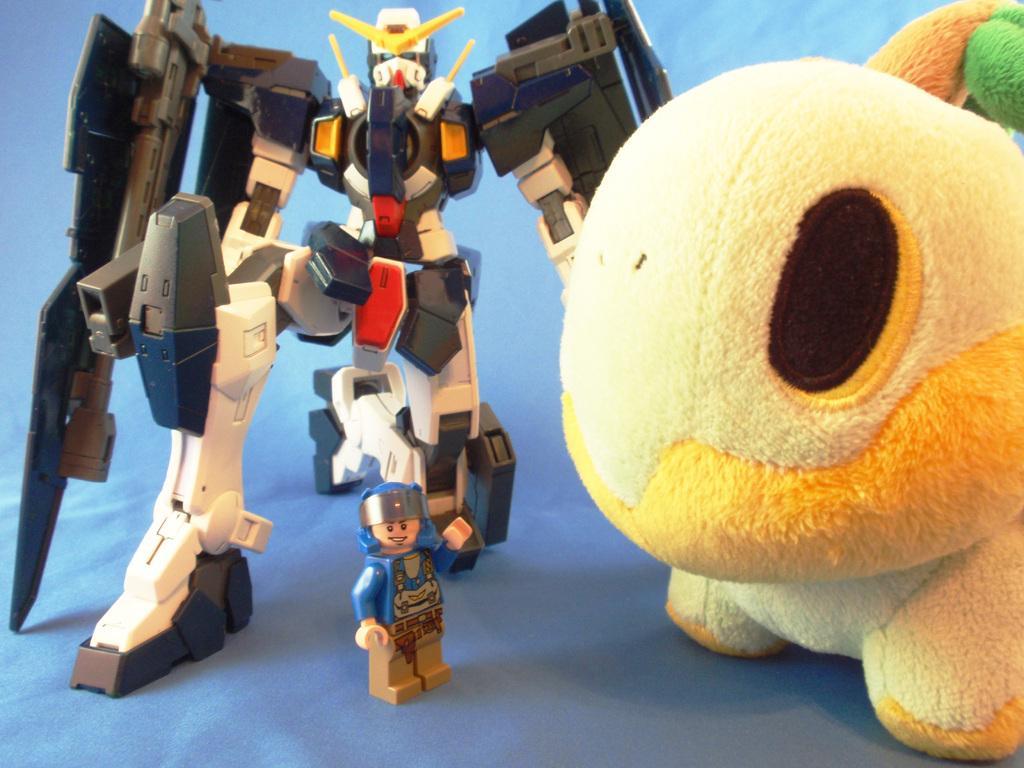Can you describe this image briefly? In the image we can see there is a robot statue and a human statue kept on the table. There is a soft toy kept on the table. 